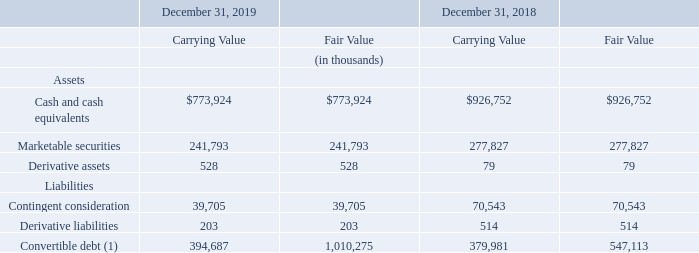The carrying amounts and fair values of Teradyne’s financial instruments at December 31, 2019 and 2018 were as follows:
(1) The carrying value represents the bifurcated debt component only, while the fair value is based on quoted market prices for the convertible note which includes the equity conversion features.
The fair values of accounts receivable, net and accounts payable approximate the carrying amount due to the short term nature of these instruments.
What does the carrying value of convertible debt represent? The bifurcated debt component only, while the fair value is based on quoted market prices for the convertible note which includes the equity conversion features. What do the fair values of accounts receivable, net and accounts payable approximate? The carrying amount due to the short term nature of these instruments. In which years were the carrying amounts and fair values of Teradyne’s financial instruments recorded? 2019, 2018. In which year was the fair value of Derivative assets larger? 528>79
Answer: 2019. What was the change in the fair value of Marketable securities from 2018 to 2019?
Answer scale should be: thousand. 241,793-277,827
Answer: -36034. What was the percentage change in the fair value of Marketable securities from 2018 to 2019?
Answer scale should be: percent. (241,793-277,827)/277,827
Answer: -12.97. 